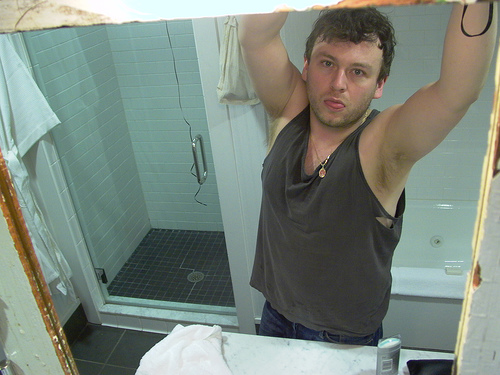<image>
Can you confirm if the man is in the shower? No. The man is not contained within the shower. These objects have a different spatial relationship. 